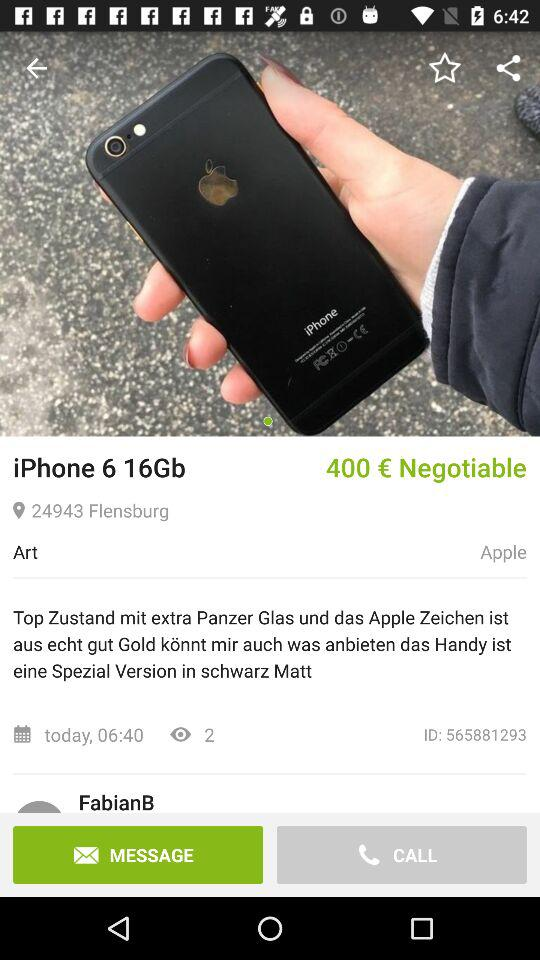What is the price of the iPhone 6?
Answer the question using a single word or phrase. 400 € Negotiable 